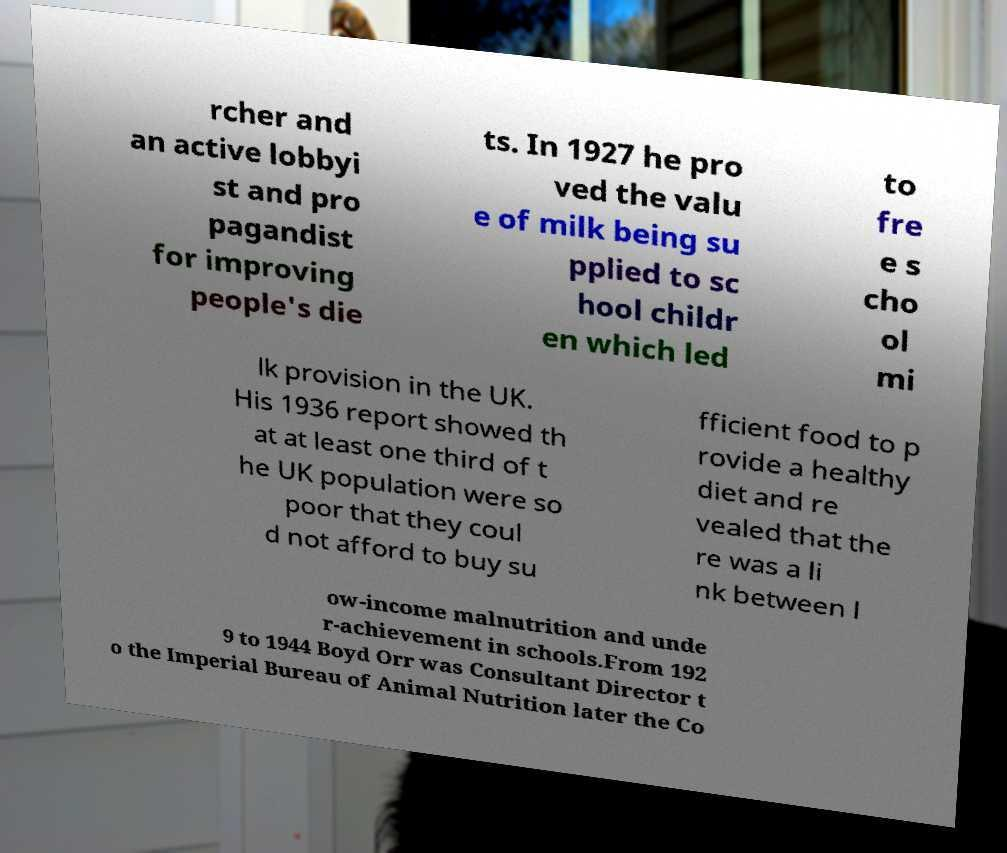Please identify and transcribe the text found in this image. rcher and an active lobbyi st and pro pagandist for improving people's die ts. In 1927 he pro ved the valu e of milk being su pplied to sc hool childr en which led to fre e s cho ol mi lk provision in the UK. His 1936 report showed th at at least one third of t he UK population were so poor that they coul d not afford to buy su fficient food to p rovide a healthy diet and re vealed that the re was a li nk between l ow-income malnutrition and unde r-achievement in schools.From 192 9 to 1944 Boyd Orr was Consultant Director t o the Imperial Bureau of Animal Nutrition later the Co 